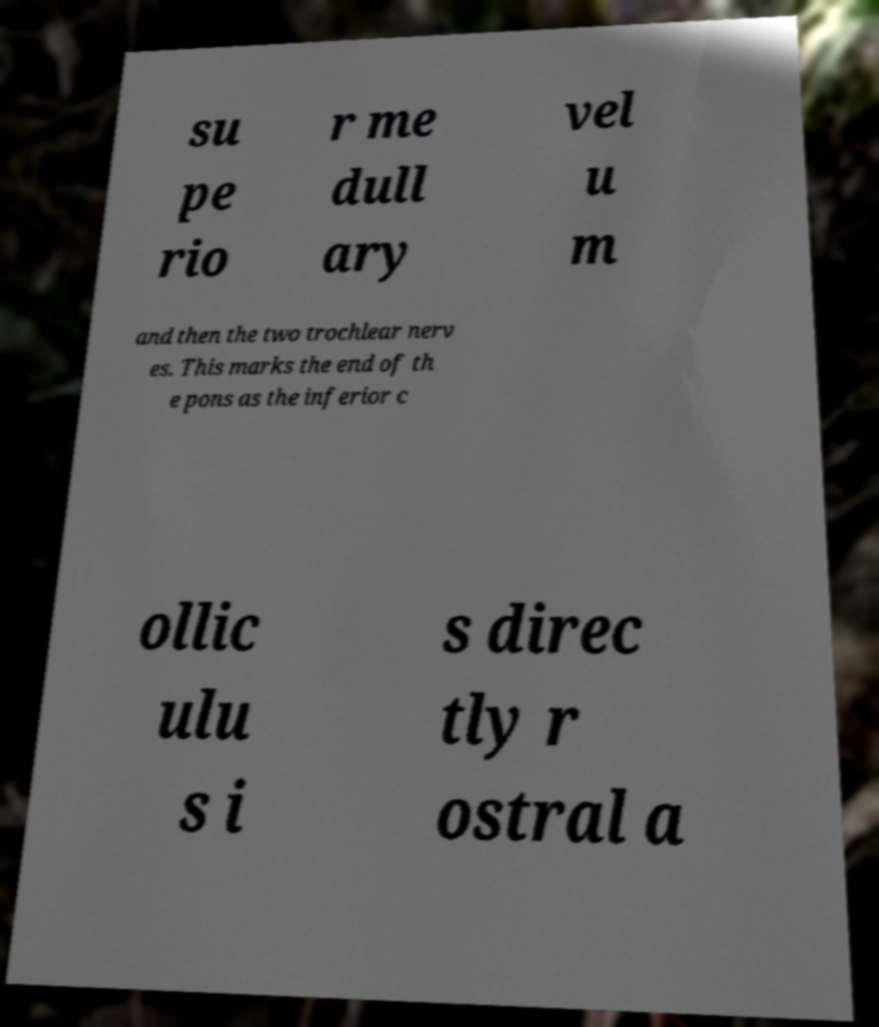Please identify and transcribe the text found in this image. su pe rio r me dull ary vel u m and then the two trochlear nerv es. This marks the end of th e pons as the inferior c ollic ulu s i s direc tly r ostral a 